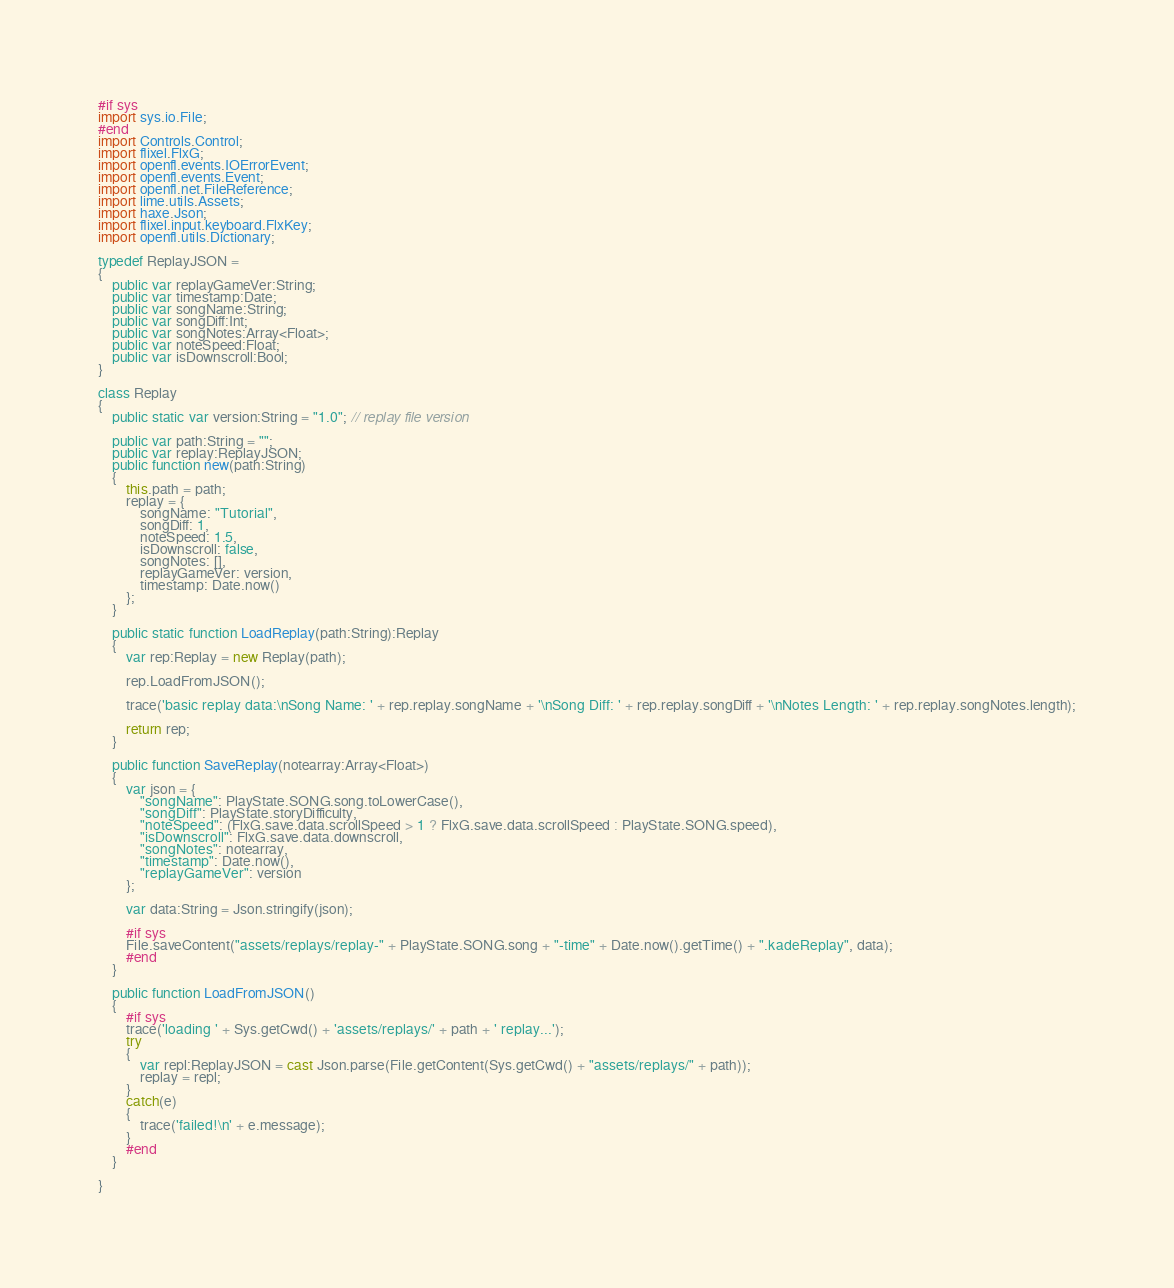Convert code to text. <code><loc_0><loc_0><loc_500><loc_500><_Haxe_>#if sys
import sys.io.File;
#end
import Controls.Control;
import flixel.FlxG;
import openfl.events.IOErrorEvent;
import openfl.events.Event;
import openfl.net.FileReference;
import lime.utils.Assets;
import haxe.Json;
import flixel.input.keyboard.FlxKey;
import openfl.utils.Dictionary;

typedef ReplayJSON =
{
    public var replayGameVer:String;
    public var timestamp:Date;
    public var songName:String;
    public var songDiff:Int;
    public var songNotes:Array<Float>;
	public var noteSpeed:Float;
	public var isDownscroll:Bool;
}

class Replay
{
    public static var version:String = "1.0"; // replay file version

    public var path:String = "";
    public var replay:ReplayJSON;
    public function new(path:String)
    {
        this.path = path;
        replay = {
            songName: "Tutorial", 
            songDiff: 1,
			noteSpeed: 1.5,
			isDownscroll: false,
			songNotes: [],
            replayGameVer: version,
            timestamp: Date.now()
        };
    }

    public static function LoadReplay(path:String):Replay
    {
        var rep:Replay = new Replay(path);

        rep.LoadFromJSON();

        trace('basic replay data:\nSong Name: ' + rep.replay.songName + '\nSong Diff: ' + rep.replay.songDiff + '\nNotes Length: ' + rep.replay.songNotes.length);

        return rep;
    }

    public function SaveReplay(notearray:Array<Float>)
    {
        var json = {
            "songName": PlayState.SONG.song.toLowerCase(),
            "songDiff": PlayState.storyDifficulty,
			"noteSpeed": (FlxG.save.data.scrollSpeed > 1 ? FlxG.save.data.scrollSpeed : PlayState.SONG.speed),
			"isDownscroll": FlxG.save.data.downscroll,
			"songNotes": notearray,
            "timestamp": Date.now(),
            "replayGameVer": version
        };

        var data:String = Json.stringify(json);

        #if sys
        File.saveContent("assets/replays/replay-" + PlayState.SONG.song + "-time" + Date.now().getTime() + ".kadeReplay", data);
        #end
    }

    public function LoadFromJSON()
    {
        #if sys
        trace('loading ' + Sys.getCwd() + 'assets/replays/' + path + ' replay...');
        try
        {
            var repl:ReplayJSON = cast Json.parse(File.getContent(Sys.getCwd() + "assets/replays/" + path));
            replay = repl;
        }
        catch(e)
        {
            trace('failed!\n' + e.message);
        }
        #end
    }

}
</code> 